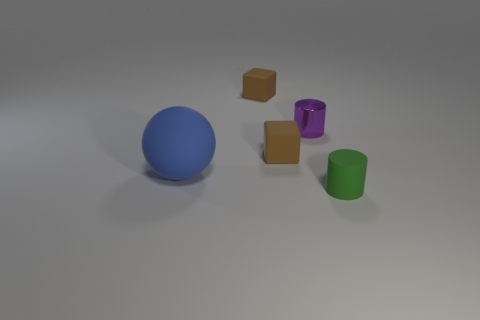Add 2 cylinders. How many objects exist? 7 Subtract all spheres. How many objects are left? 4 Subtract 1 purple cylinders. How many objects are left? 4 Subtract all yellow rubber objects. Subtract all rubber spheres. How many objects are left? 4 Add 4 large rubber spheres. How many large rubber spheres are left? 5 Add 5 small purple shiny things. How many small purple shiny things exist? 6 